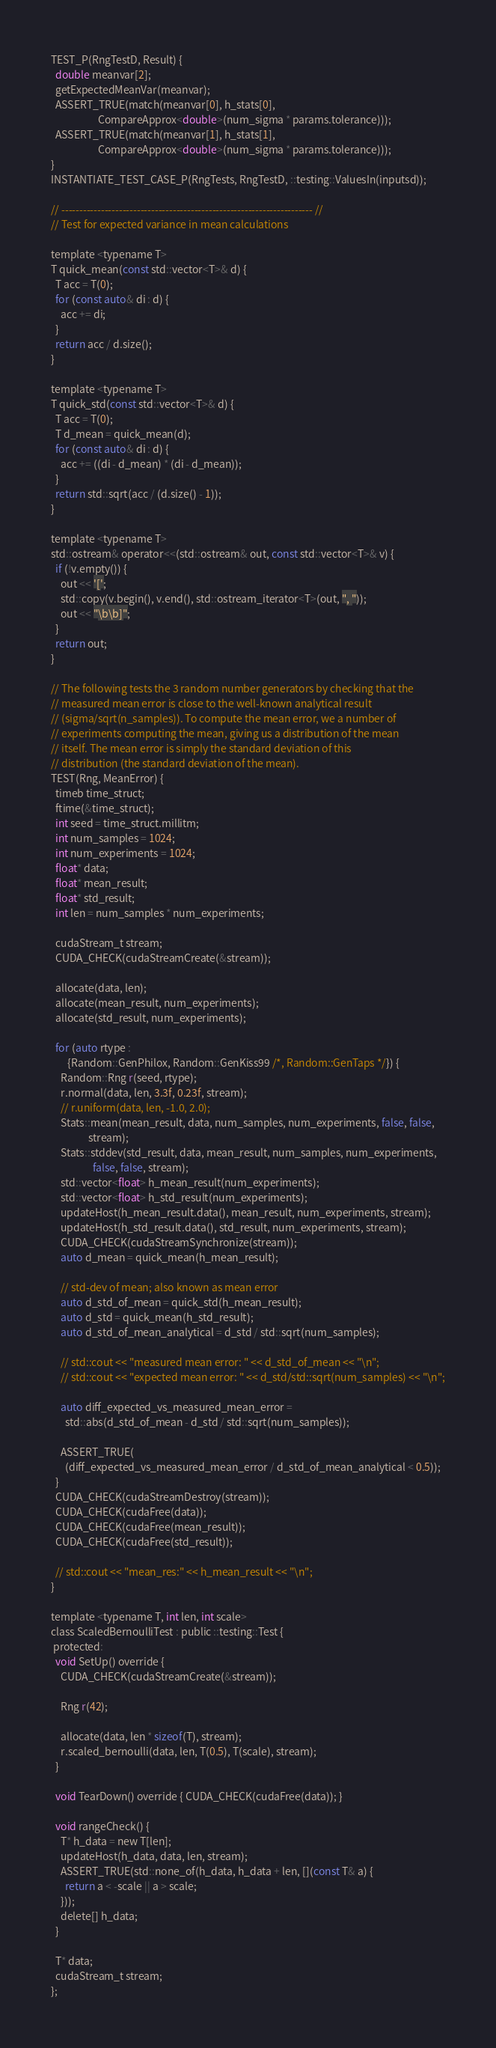Convert code to text. <code><loc_0><loc_0><loc_500><loc_500><_Cuda_>TEST_P(RngTestD, Result) {
  double meanvar[2];
  getExpectedMeanVar(meanvar);
  ASSERT_TRUE(match(meanvar[0], h_stats[0],
                    CompareApprox<double>(num_sigma * params.tolerance)));
  ASSERT_TRUE(match(meanvar[1], h_stats[1],
                    CompareApprox<double>(num_sigma * params.tolerance)));
}
INSTANTIATE_TEST_CASE_P(RngTests, RngTestD, ::testing::ValuesIn(inputsd));

// ---------------------------------------------------------------------- //
// Test for expected variance in mean calculations

template <typename T>
T quick_mean(const std::vector<T>& d) {
  T acc = T(0);
  for (const auto& di : d) {
    acc += di;
  }
  return acc / d.size();
}

template <typename T>
T quick_std(const std::vector<T>& d) {
  T acc = T(0);
  T d_mean = quick_mean(d);
  for (const auto& di : d) {
    acc += ((di - d_mean) * (di - d_mean));
  }
  return std::sqrt(acc / (d.size() - 1));
}

template <typename T>
std::ostream& operator<<(std::ostream& out, const std::vector<T>& v) {
  if (!v.empty()) {
    out << '[';
    std::copy(v.begin(), v.end(), std::ostream_iterator<T>(out, ", "));
    out << "\b\b]";
  }
  return out;
}

// The following tests the 3 random number generators by checking that the
// measured mean error is close to the well-known analytical result
// (sigma/sqrt(n_samples)). To compute the mean error, we a number of
// experiments computing the mean, giving us a distribution of the mean
// itself. The mean error is simply the standard deviation of this
// distribution (the standard deviation of the mean).
TEST(Rng, MeanError) {
  timeb time_struct;
  ftime(&time_struct);
  int seed = time_struct.millitm;
  int num_samples = 1024;
  int num_experiments = 1024;
  float* data;
  float* mean_result;
  float* std_result;
  int len = num_samples * num_experiments;

  cudaStream_t stream;
  CUDA_CHECK(cudaStreamCreate(&stream));

  allocate(data, len);
  allocate(mean_result, num_experiments);
  allocate(std_result, num_experiments);

  for (auto rtype :
       {Random::GenPhilox, Random::GenKiss99 /*, Random::GenTaps */}) {
    Random::Rng r(seed, rtype);
    r.normal(data, len, 3.3f, 0.23f, stream);
    // r.uniform(data, len, -1.0, 2.0);
    Stats::mean(mean_result, data, num_samples, num_experiments, false, false,
                stream);
    Stats::stddev(std_result, data, mean_result, num_samples, num_experiments,
                  false, false, stream);
    std::vector<float> h_mean_result(num_experiments);
    std::vector<float> h_std_result(num_experiments);
    updateHost(h_mean_result.data(), mean_result, num_experiments, stream);
    updateHost(h_std_result.data(), std_result, num_experiments, stream);
    CUDA_CHECK(cudaStreamSynchronize(stream));
    auto d_mean = quick_mean(h_mean_result);

    // std-dev of mean; also known as mean error
    auto d_std_of_mean = quick_std(h_mean_result);
    auto d_std = quick_mean(h_std_result);
    auto d_std_of_mean_analytical = d_std / std::sqrt(num_samples);

    // std::cout << "measured mean error: " << d_std_of_mean << "\n";
    // std::cout << "expected mean error: " << d_std/std::sqrt(num_samples) << "\n";

    auto diff_expected_vs_measured_mean_error =
      std::abs(d_std_of_mean - d_std / std::sqrt(num_samples));

    ASSERT_TRUE(
      (diff_expected_vs_measured_mean_error / d_std_of_mean_analytical < 0.5));
  }
  CUDA_CHECK(cudaStreamDestroy(stream));
  CUDA_CHECK(cudaFree(data));
  CUDA_CHECK(cudaFree(mean_result));
  CUDA_CHECK(cudaFree(std_result));

  // std::cout << "mean_res:" << h_mean_result << "\n";
}

template <typename T, int len, int scale>
class ScaledBernoulliTest : public ::testing::Test {
 protected:
  void SetUp() override {
    CUDA_CHECK(cudaStreamCreate(&stream));

    Rng r(42);

    allocate(data, len * sizeof(T), stream);
    r.scaled_bernoulli(data, len, T(0.5), T(scale), stream);
  }

  void TearDown() override { CUDA_CHECK(cudaFree(data)); }

  void rangeCheck() {
    T* h_data = new T[len];
    updateHost(h_data, data, len, stream);
    ASSERT_TRUE(std::none_of(h_data, h_data + len, [](const T& a) {
      return a < -scale || a > scale;
    }));
    delete[] h_data;
  }

  T* data;
  cudaStream_t stream;
};
</code> 